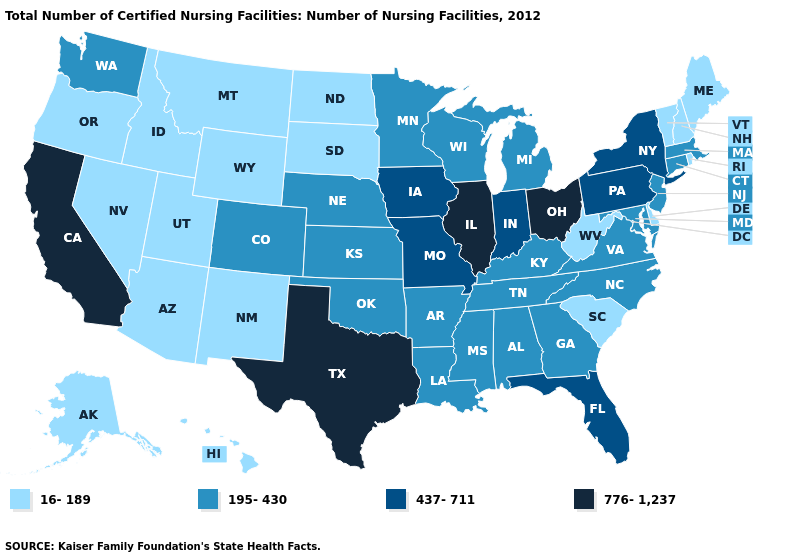Does Arizona have the lowest value in the USA?
Write a very short answer. Yes. Which states have the lowest value in the USA?
Give a very brief answer. Alaska, Arizona, Delaware, Hawaii, Idaho, Maine, Montana, Nevada, New Hampshire, New Mexico, North Dakota, Oregon, Rhode Island, South Carolina, South Dakota, Utah, Vermont, West Virginia, Wyoming. Which states have the lowest value in the West?
Keep it brief. Alaska, Arizona, Hawaii, Idaho, Montana, Nevada, New Mexico, Oregon, Utah, Wyoming. Name the states that have a value in the range 437-711?
Keep it brief. Florida, Indiana, Iowa, Missouri, New York, Pennsylvania. Among the states that border New Hampshire , does Massachusetts have the lowest value?
Keep it brief. No. How many symbols are there in the legend?
Answer briefly. 4. What is the lowest value in states that border Minnesota?
Keep it brief. 16-189. Among the states that border Texas , which have the lowest value?
Be succinct. New Mexico. Which states have the lowest value in the West?
Give a very brief answer. Alaska, Arizona, Hawaii, Idaho, Montana, Nevada, New Mexico, Oregon, Utah, Wyoming. What is the value of Rhode Island?
Quick response, please. 16-189. Does Utah have a lower value than Louisiana?
Answer briefly. Yes. Which states have the highest value in the USA?
Write a very short answer. California, Illinois, Ohio, Texas. Which states have the lowest value in the USA?
Be succinct. Alaska, Arizona, Delaware, Hawaii, Idaho, Maine, Montana, Nevada, New Hampshire, New Mexico, North Dakota, Oregon, Rhode Island, South Carolina, South Dakota, Utah, Vermont, West Virginia, Wyoming. What is the value of Arizona?
Quick response, please. 16-189. 